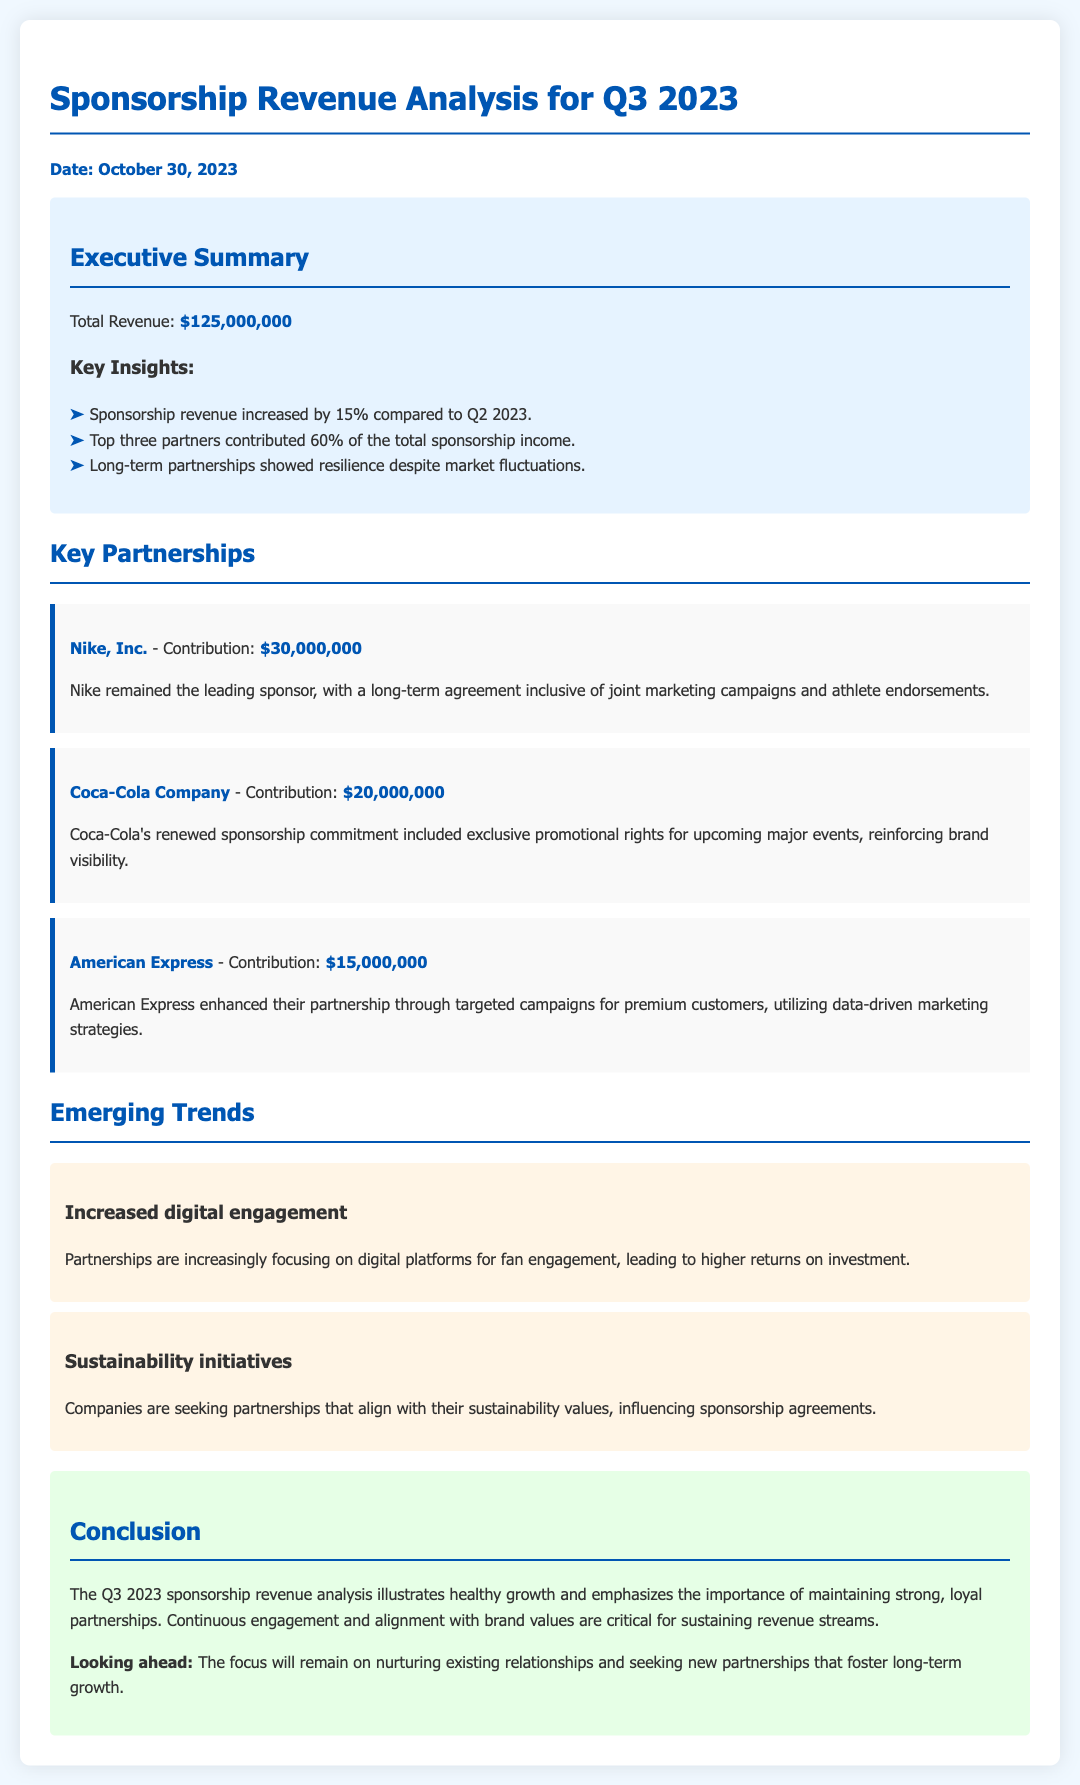What is the total revenue for Q3 2023? The total revenue is stated in the document as $125,000,000.
Answer: $125,000,000 Who is the leading sponsor? The leading sponsor mentioned in the document is Nike, Inc.
Answer: Nike, Inc How much did Coca-Cola Company contribute? The contribution from Coca-Cola Company is noted as $20,000,000.
Answer: $20,000,000 What percentage of total sponsorship income was contributed by the top three partners? The document indicates that the top three partners contributed 60% of total sponsorship income.
Answer: 60% What trend is mentioned regarding digital engagement? The document states that partnerships are increasingly focusing on digital platforms for fan engagement.
Answer: Increased digital engagement What is the importance of long-term partnerships according to the report? The report highlights that long-term partnerships showed resilience despite market fluctuations.
Answer: Resilience What is one key factor emphasized for sustaining revenue streams? The report emphasizes continuous engagement and alignment with brand values as critical for sustaining revenue streams.
Answer: Continuous engagement and alignment with brand values What is the date the analysis was published? The analysis was published on October 30, 2023.
Answer: October 30, 2023 